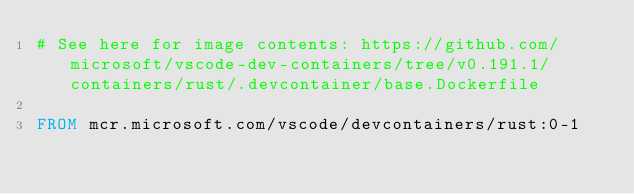<code> <loc_0><loc_0><loc_500><loc_500><_Dockerfile_># See here for image contents: https://github.com/microsoft/vscode-dev-containers/tree/v0.191.1/containers/rust/.devcontainer/base.Dockerfile

FROM mcr.microsoft.com/vscode/devcontainers/rust:0-1
</code> 